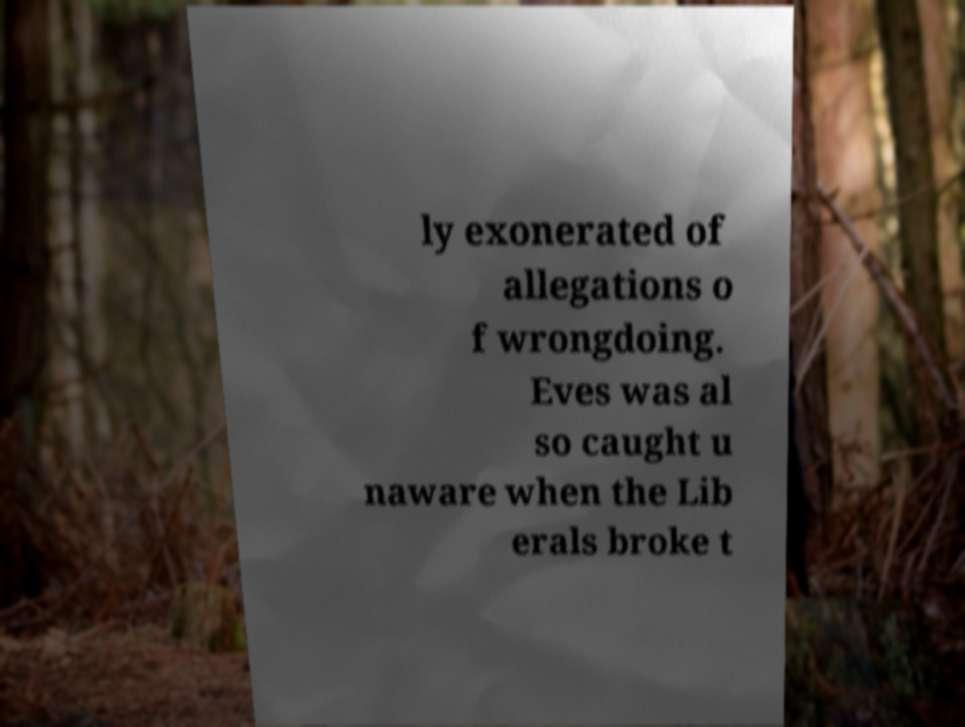There's text embedded in this image that I need extracted. Can you transcribe it verbatim? ly exonerated of allegations o f wrongdoing. Eves was al so caught u naware when the Lib erals broke t 